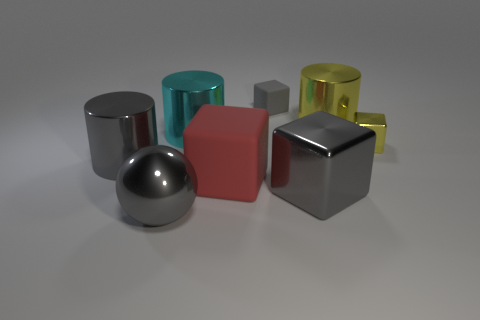Add 1 big blue shiny objects. How many objects exist? 9 Subtract all small yellow cubes. How many cubes are left? 3 Subtract all gray blocks. How many blocks are left? 2 Subtract 2 cylinders. How many cylinders are left? 1 Subtract all balls. How many objects are left? 7 Subtract all cyan balls. Subtract all gray cubes. How many balls are left? 1 Subtract all gray blocks. How many yellow spheres are left? 0 Subtract 0 blue blocks. How many objects are left? 8 Subtract all large objects. Subtract all red rubber things. How many objects are left? 1 Add 3 balls. How many balls are left? 4 